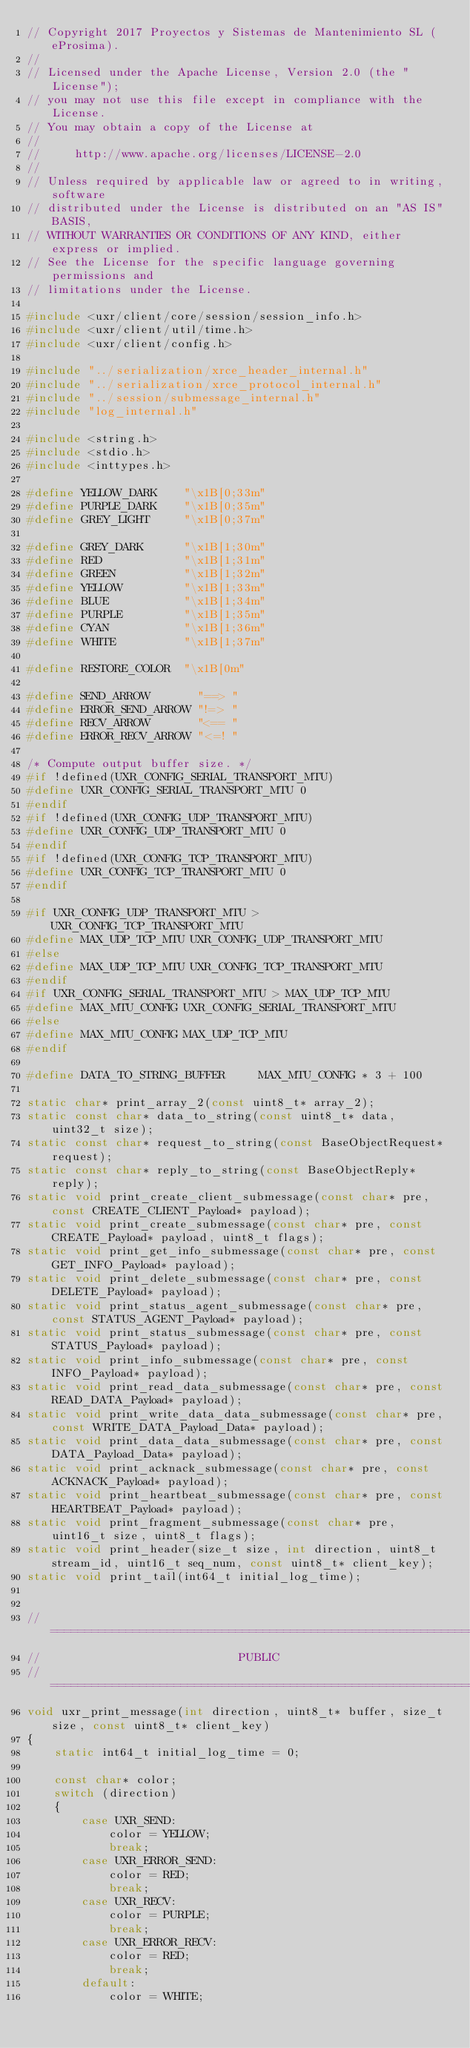<code> <loc_0><loc_0><loc_500><loc_500><_C_>// Copyright 2017 Proyectos y Sistemas de Mantenimiento SL (eProsima).
//
// Licensed under the Apache License, Version 2.0 (the "License");
// you may not use this file except in compliance with the License.
// You may obtain a copy of the License at
//
//     http://www.apache.org/licenses/LICENSE-2.0
//
// Unless required by applicable law or agreed to in writing, software
// distributed under the License is distributed on an "AS IS" BASIS,
// WITHOUT WARRANTIES OR CONDITIONS OF ANY KIND, either express or implied.
// See the License for the specific language governing permissions and
// limitations under the License.

#include <uxr/client/core/session/session_info.h>
#include <uxr/client/util/time.h>
#include <uxr/client/config.h>

#include "../serialization/xrce_header_internal.h"
#include "../serialization/xrce_protocol_internal.h"
#include "../session/submessage_internal.h"
#include "log_internal.h"

#include <string.h>
#include <stdio.h>
#include <inttypes.h>

#define YELLOW_DARK    "\x1B[0;33m"
#define PURPLE_DARK    "\x1B[0;35m"
#define GREY_LIGHT     "\x1B[0;37m"

#define GREY_DARK      "\x1B[1;30m"
#define RED            "\x1B[1;31m"
#define GREEN          "\x1B[1;32m"
#define YELLOW         "\x1B[1;33m"
#define BLUE           "\x1B[1;34m"
#define PURPLE         "\x1B[1;35m"
#define CYAN           "\x1B[1;36m"
#define WHITE          "\x1B[1;37m"

#define RESTORE_COLOR  "\x1B[0m"

#define SEND_ARROW       "==> "
#define ERROR_SEND_ARROW "!=> "
#define RECV_ARROW       "<== "
#define ERROR_RECV_ARROW "<=! "

/* Compute output buffer size. */
#if !defined(UXR_CONFIG_SERIAL_TRANSPORT_MTU)
#define UXR_CONFIG_SERIAL_TRANSPORT_MTU 0
#endif
#if !defined(UXR_CONFIG_UDP_TRANSPORT_MTU)
#define UXR_CONFIG_UDP_TRANSPORT_MTU 0
#endif
#if !defined(UXR_CONFIG_TCP_TRANSPORT_MTU)
#define UXR_CONFIG_TCP_TRANSPORT_MTU 0
#endif

#if UXR_CONFIG_UDP_TRANSPORT_MTU > UXR_CONFIG_TCP_TRANSPORT_MTU
#define MAX_UDP_TCP_MTU UXR_CONFIG_UDP_TRANSPORT_MTU
#else
#define MAX_UDP_TCP_MTU UXR_CONFIG_TCP_TRANSPORT_MTU
#endif
#if UXR_CONFIG_SERIAL_TRANSPORT_MTU > MAX_UDP_TCP_MTU
#define MAX_MTU_CONFIG UXR_CONFIG_SERIAL_TRANSPORT_MTU
#else
#define MAX_MTU_CONFIG MAX_UDP_TCP_MTU
#endif

#define DATA_TO_STRING_BUFFER     MAX_MTU_CONFIG * 3 + 100

static char* print_array_2(const uint8_t* array_2);
static const char* data_to_string(const uint8_t* data, uint32_t size);
static const char* request_to_string(const BaseObjectRequest* request);
static const char* reply_to_string(const BaseObjectReply* reply);
static void print_create_client_submessage(const char* pre, const CREATE_CLIENT_Payload* payload);
static void print_create_submessage(const char* pre, const CREATE_Payload* payload, uint8_t flags);
static void print_get_info_submessage(const char* pre, const GET_INFO_Payload* payload);
static void print_delete_submessage(const char* pre, const DELETE_Payload* payload);
static void print_status_agent_submessage(const char* pre, const STATUS_AGENT_Payload* payload);
static void print_status_submessage(const char* pre, const STATUS_Payload* payload);
static void print_info_submessage(const char* pre, const INFO_Payload* payload);
static void print_read_data_submessage(const char* pre, const READ_DATA_Payload* payload);
static void print_write_data_data_submessage(const char* pre, const WRITE_DATA_Payload_Data* payload);
static void print_data_data_submessage(const char* pre, const DATA_Payload_Data* payload);
static void print_acknack_submessage(const char* pre, const ACKNACK_Payload* payload);
static void print_heartbeat_submessage(const char* pre, const HEARTBEAT_Payload* payload);
static void print_fragment_submessage(const char* pre, uint16_t size, uint8_t flags);
static void print_header(size_t size, int direction, uint8_t stream_id, uint16_t seq_num, const uint8_t* client_key);
static void print_tail(int64_t initial_log_time);


//==================================================================
//                             PUBLIC
//==================================================================
void uxr_print_message(int direction, uint8_t* buffer, size_t size, const uint8_t* client_key)
{
    static int64_t initial_log_time = 0;

    const char* color;
    switch (direction)
    {
        case UXR_SEND:
            color = YELLOW;
            break;
        case UXR_ERROR_SEND:
            color = RED;
            break;
        case UXR_RECV:
            color = PURPLE;
            break;
        case UXR_ERROR_RECV:
            color = RED;
            break;
        default:
            color = WHITE;</code> 